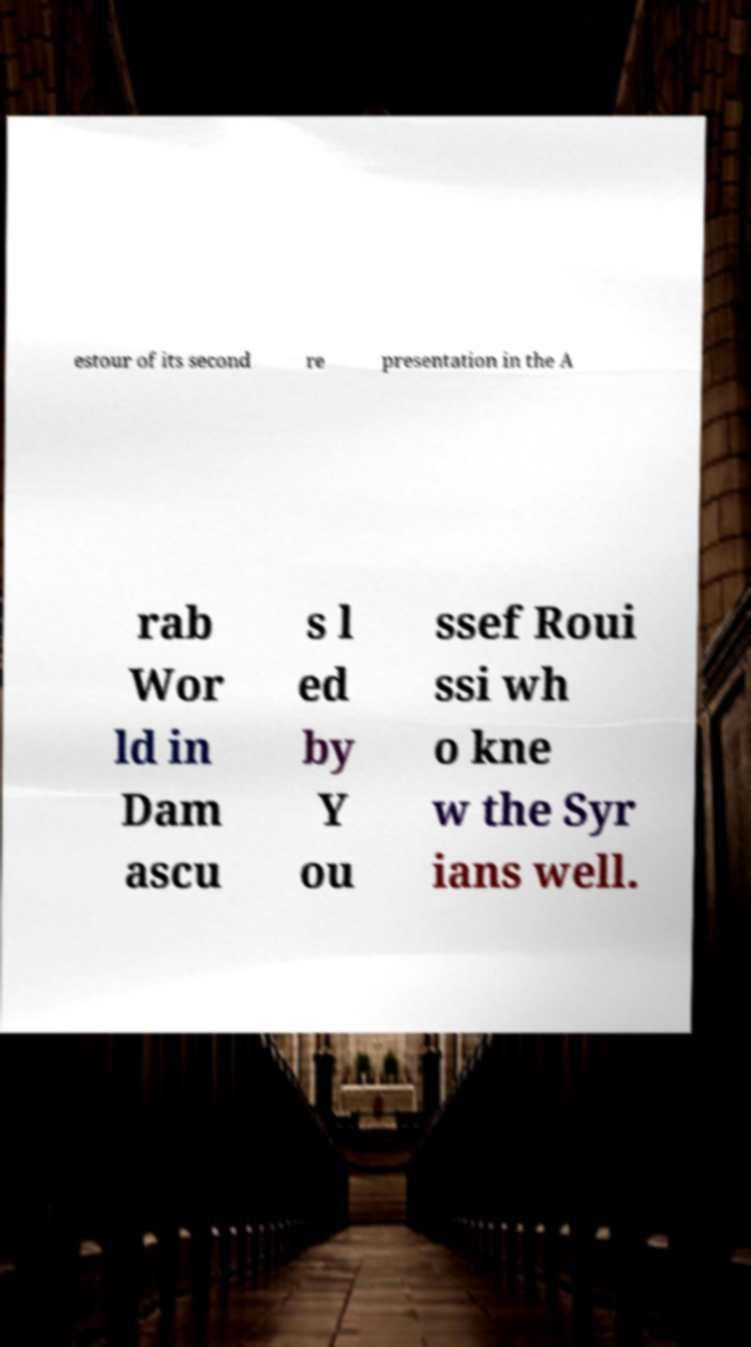Please identify and transcribe the text found in this image. estour of its second re presentation in the A rab Wor ld in Dam ascu s l ed by Y ou ssef Roui ssi wh o kne w the Syr ians well. 